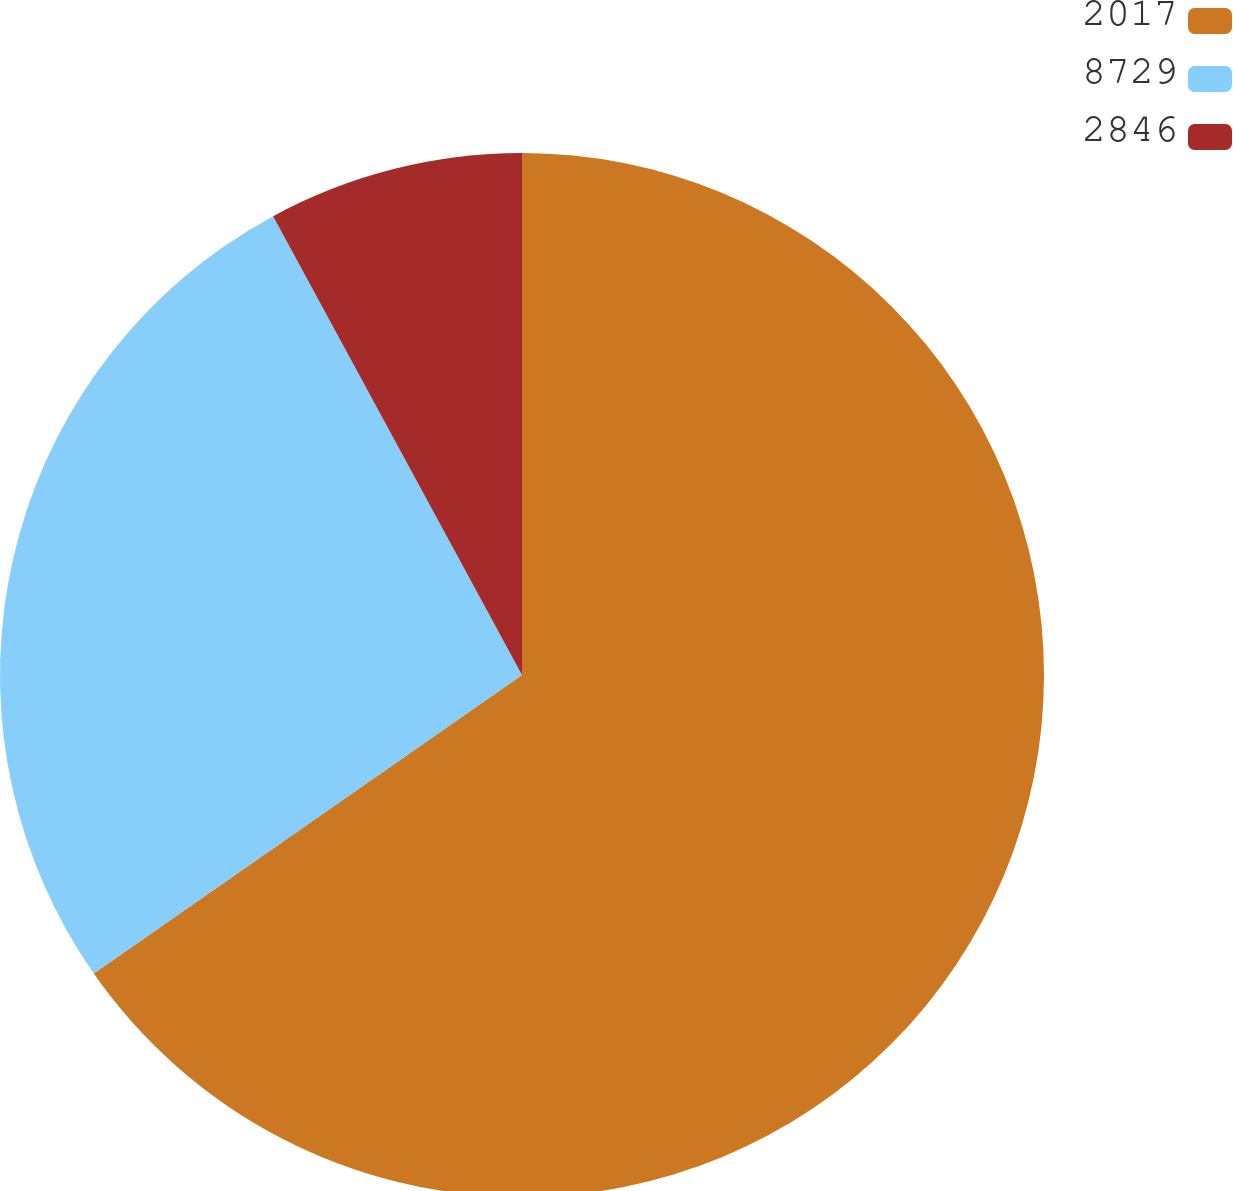Convert chart to OTSL. <chart><loc_0><loc_0><loc_500><loc_500><pie_chart><fcel>2017<fcel>8729<fcel>2846<nl><fcel>65.31%<fcel>26.78%<fcel>7.91%<nl></chart> 